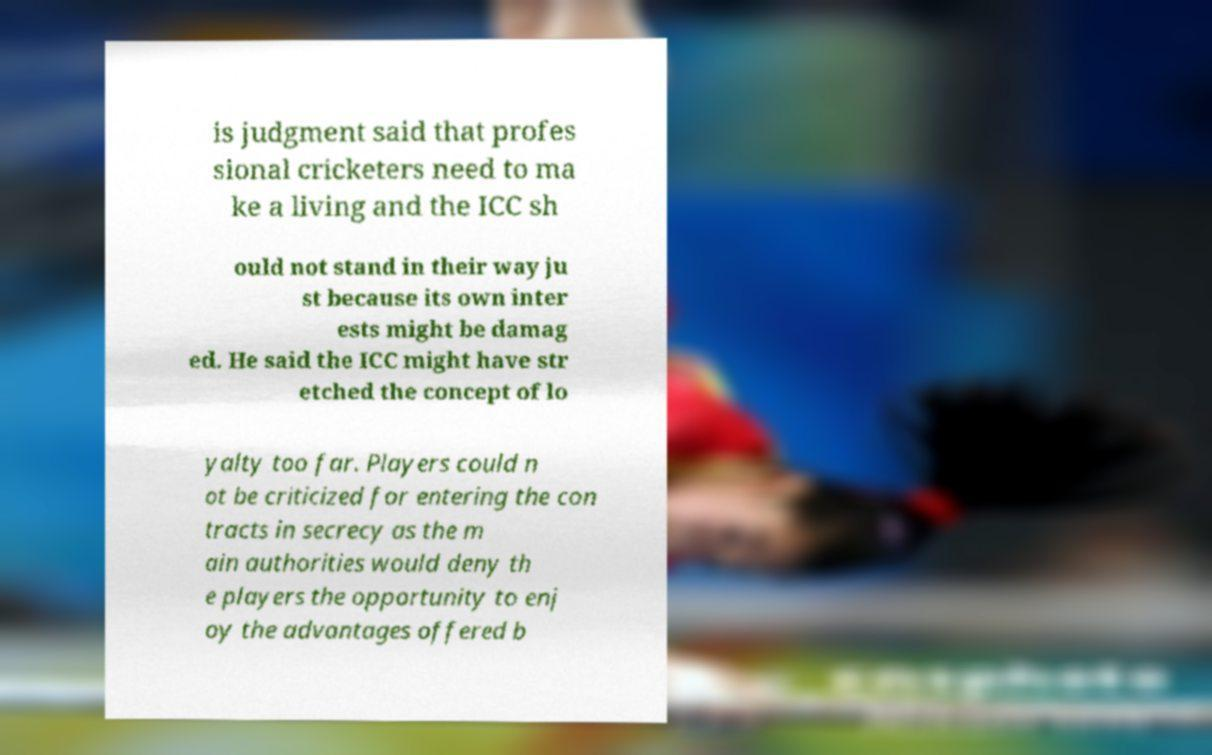I need the written content from this picture converted into text. Can you do that? is judgment said that profes sional cricketers need to ma ke a living and the ICC sh ould not stand in their way ju st because its own inter ests might be damag ed. He said the ICC might have str etched the concept of lo yalty too far. Players could n ot be criticized for entering the con tracts in secrecy as the m ain authorities would deny th e players the opportunity to enj oy the advantages offered b 